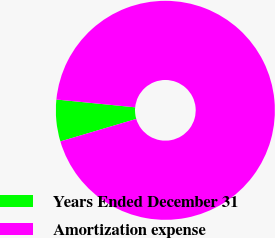<chart> <loc_0><loc_0><loc_500><loc_500><pie_chart><fcel>Years Ended December 31<fcel>Amortization expense<nl><fcel>6.16%<fcel>93.84%<nl></chart> 